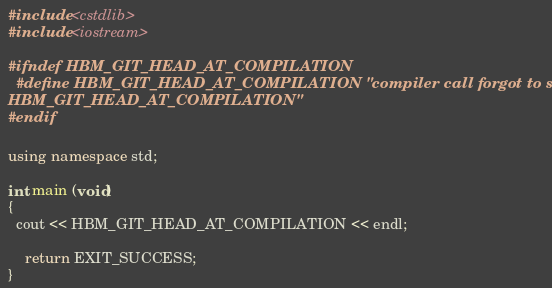<code> <loc_0><loc_0><loc_500><loc_500><_C++_>#include <cstdlib>
#include <iostream>

#ifndef HBM_GIT_HEAD_AT_COMPILATION
  #define HBM_GIT_HEAD_AT_COMPILATION "compiler call forgot to set \
HBM_GIT_HEAD_AT_COMPILATION"
#endif

using namespace std;

int main (void)
{
  cout << HBM_GIT_HEAD_AT_COMPILATION << endl;

	return EXIT_SUCCESS;
}

</code> 